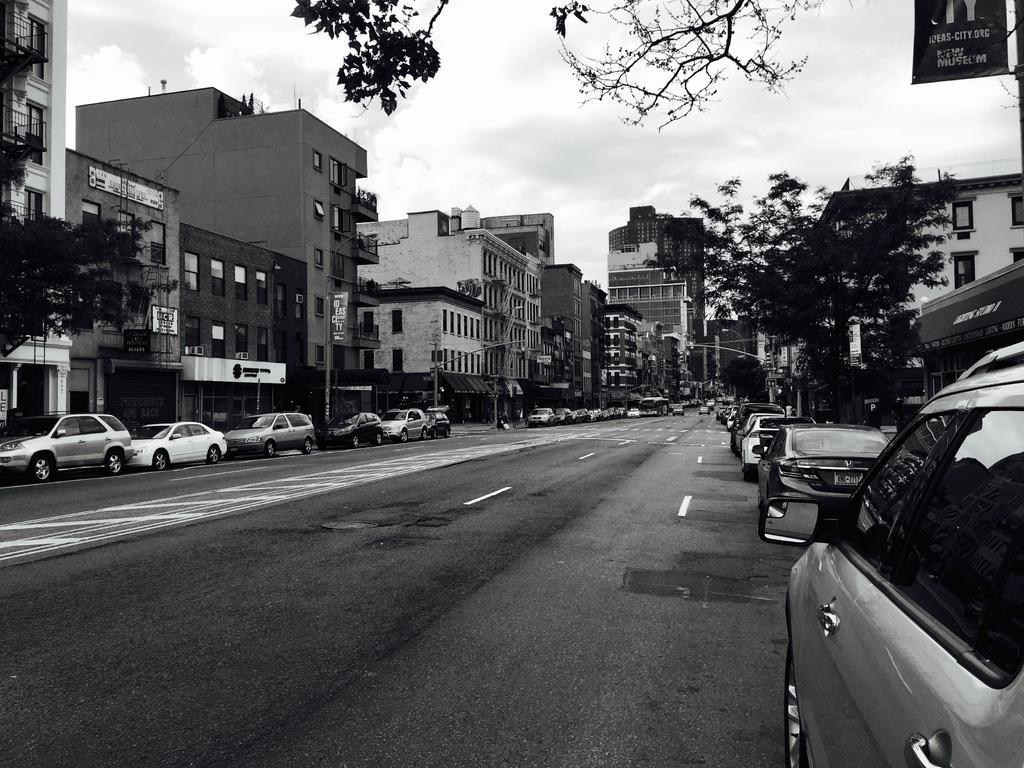Please provide a concise description of this image. In the image we can see there are cars parked on the road and behind there are trees and buildings. There is clear sky and the image is in black and white colour. 